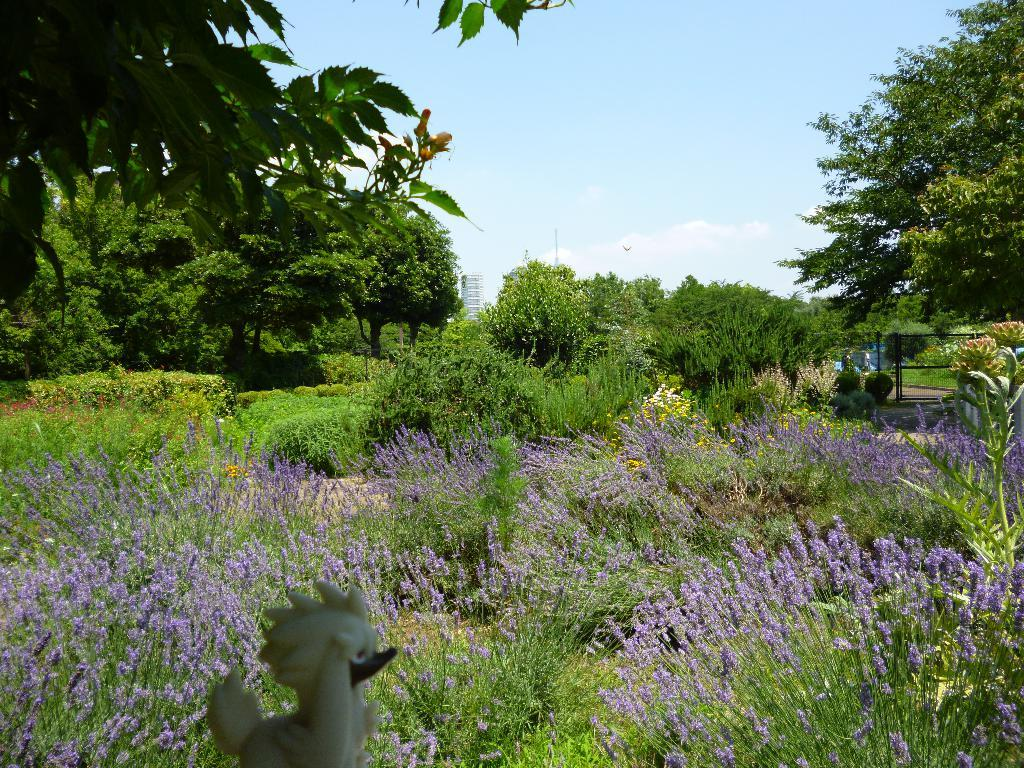What type of vegetation can be seen in the image? There are trees in the image. What is present at the bottom of the image? There is grass at the bottom of the image. What other flora can be seen in the image? There are flowers visible in the image. What is visible in the background of the image? The sky is visible in the background of the image. In which direction is the attention of the flowers in the image directed? There is no indication in the image that the flowers have any specific direction of attention. 